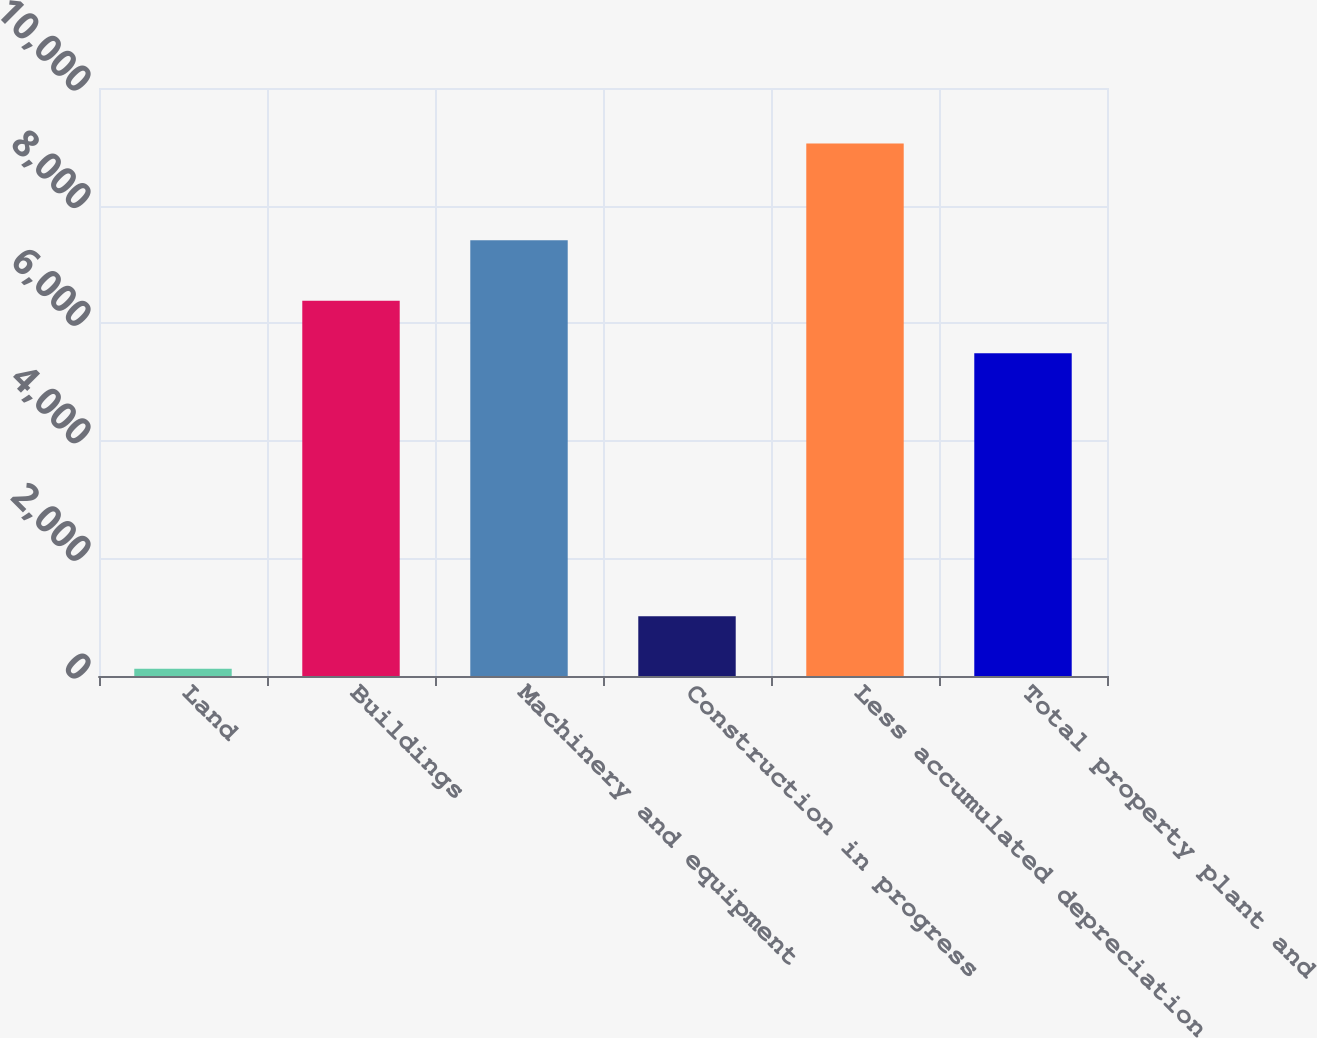<chart> <loc_0><loc_0><loc_500><loc_500><bar_chart><fcel>Land<fcel>Buildings<fcel>Machinery and equipment<fcel>Construction in progress<fcel>Less accumulated depreciation<fcel>Total property plant and<nl><fcel>123<fcel>6383.4<fcel>7409<fcel>1016.4<fcel>9057<fcel>5490<nl></chart> 